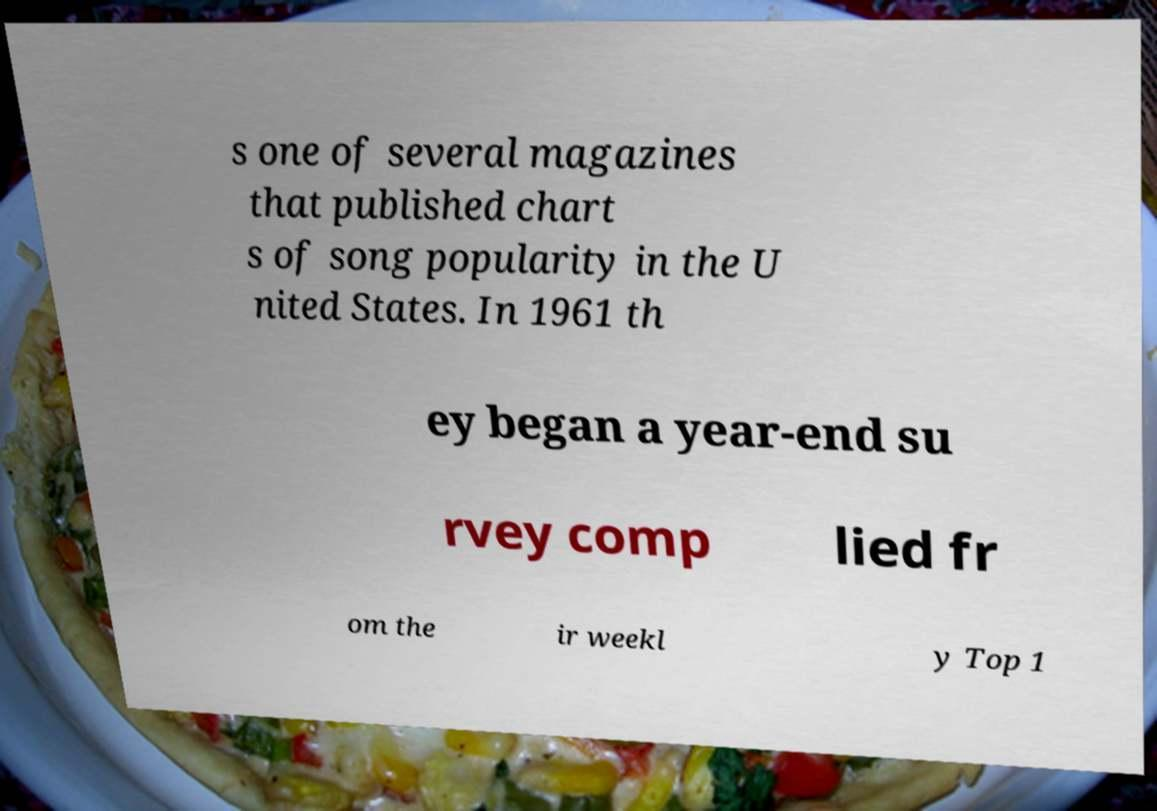Could you extract and type out the text from this image? s one of several magazines that published chart s of song popularity in the U nited States. In 1961 th ey began a year-end su rvey comp lied fr om the ir weekl y Top 1 